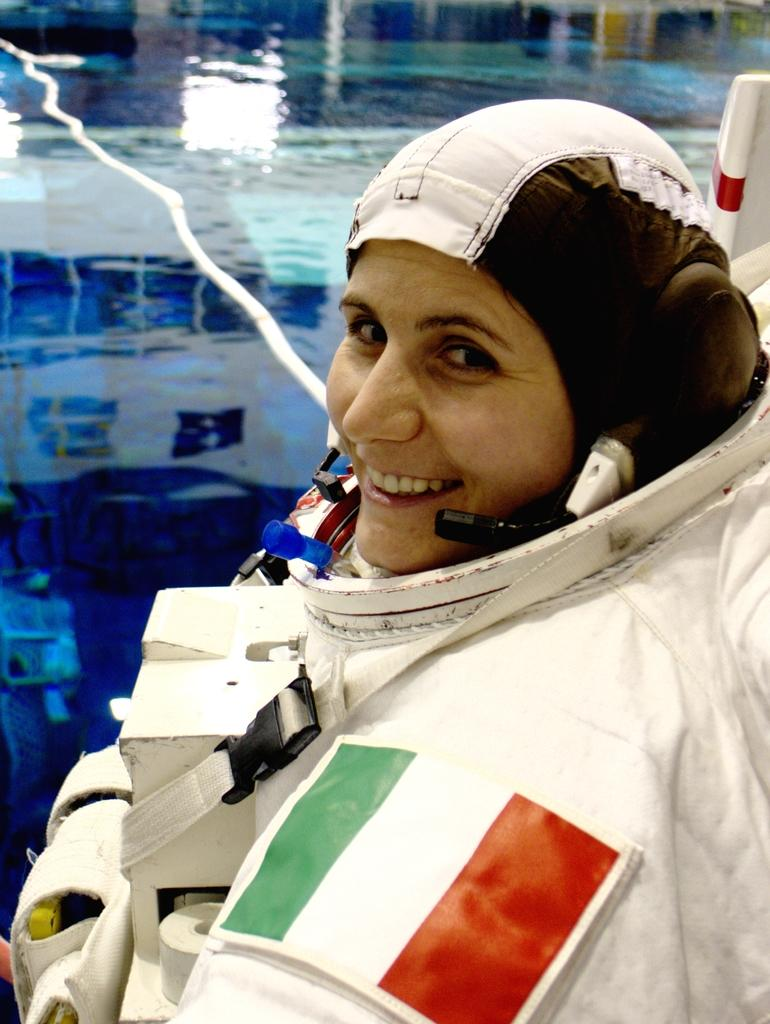Who is the main subject in the image? There is a lady in the center of the image. What is the lady doing in the image? The lady is smiling. What is the lady wearing in the image? The lady is wearing a dress and a headset. What can be seen in the background of the image? There is water visible in the background of the image. What type of cushion is the lady sitting on in the image? There is no cushion present in the image; the lady is standing. Who is the lady talking to on the phone in the image? The image does not show the lady talking on the phone, only wearing a headset. 